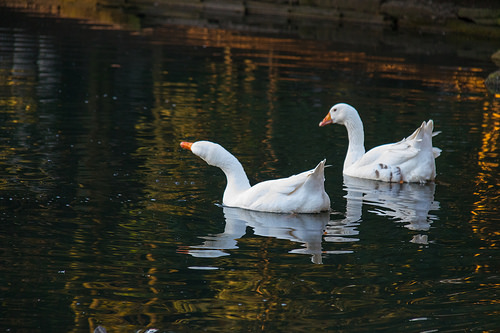<image>
Is there a ducks in the water? Yes. The ducks is contained within or inside the water, showing a containment relationship. 